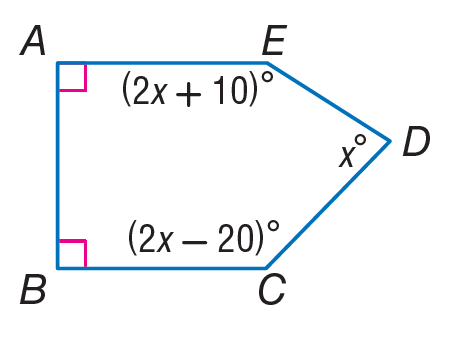Answer the mathemtical geometry problem and directly provide the correct option letter.
Question: Find m \angle C.
Choices: A: 38 B: 66 C: 72 D: 128 D 